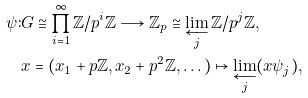Convert formula to latex. <formula><loc_0><loc_0><loc_500><loc_500>\psi \colon & G \cong \prod _ { i = 1 } ^ { \infty } \mathbb { Z } / p ^ { i } \mathbb { Z } \longrightarrow \mathbb { Z } _ { p } \cong \varprojlim _ { j } \mathbb { Z } / p ^ { j } \mathbb { Z } , \\ & x = ( x _ { 1 } + p \mathbb { Z } , x _ { 2 } + p ^ { 2 } \mathbb { Z } , \dots ) \mapsto \varprojlim _ { j } ( x \psi _ { j } ) ,</formula> 